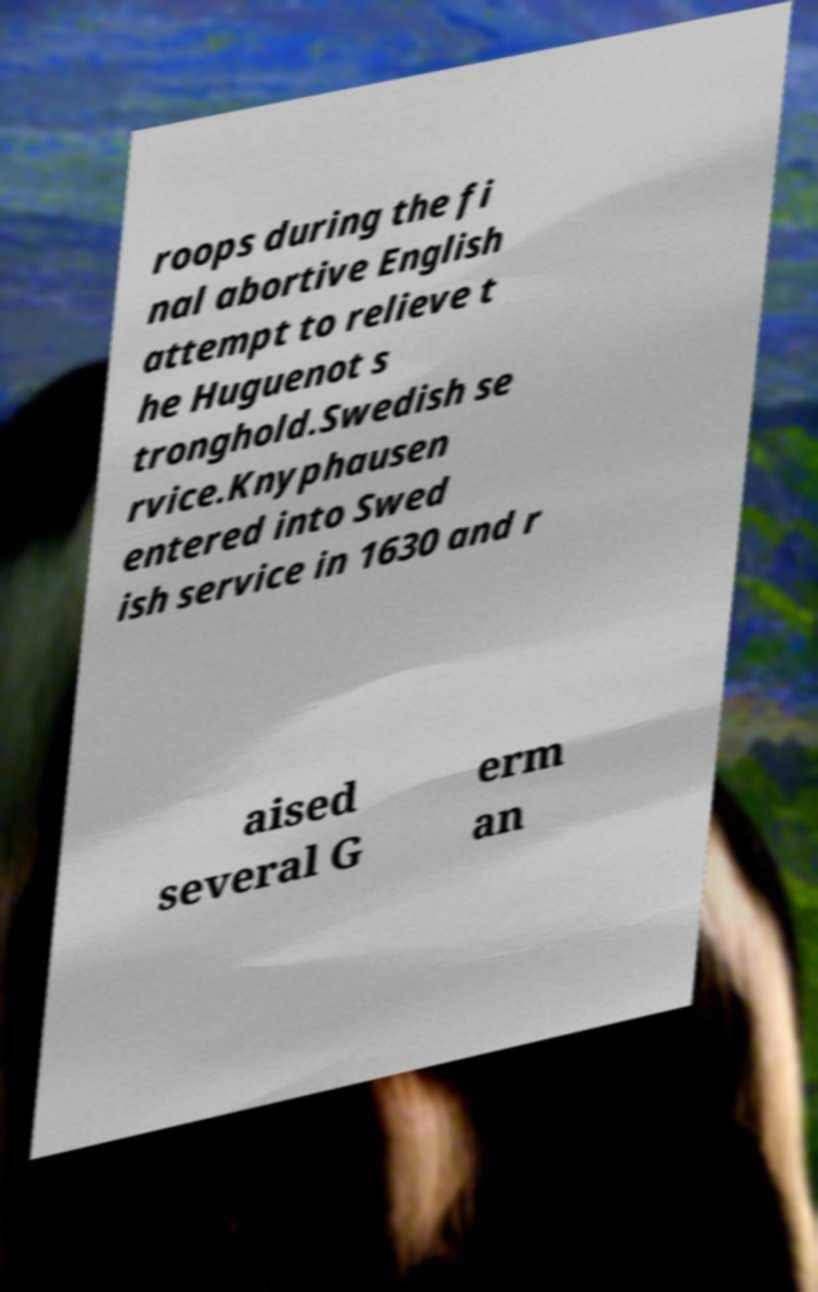Can you accurately transcribe the text from the provided image for me? roops during the fi nal abortive English attempt to relieve t he Huguenot s tronghold.Swedish se rvice.Knyphausen entered into Swed ish service in 1630 and r aised several G erm an 